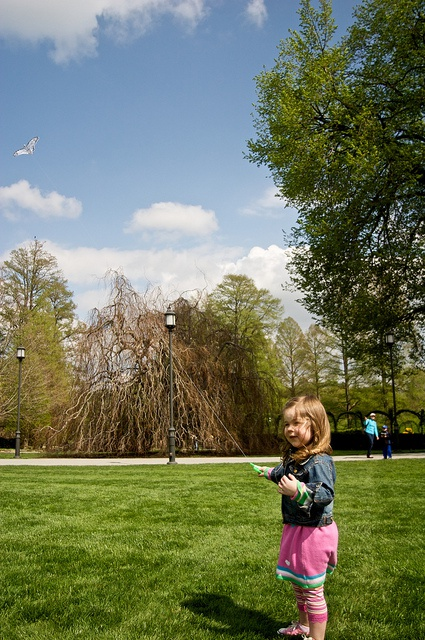Describe the objects in this image and their specific colors. I can see people in darkgray, black, lightpink, olive, and maroon tones, people in darkgray, black, lightblue, and teal tones, bird in darkgray, lightgray, and gray tones, people in darkgray, black, navy, and gray tones, and kite in darkgray, lightgray, and gray tones in this image. 